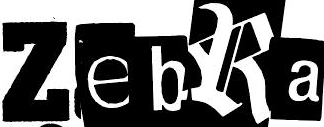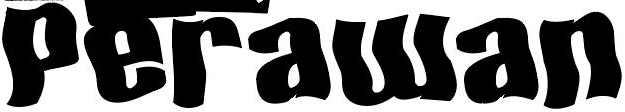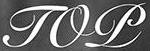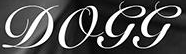Read the text content from these images in order, separated by a semicolon. ZebRa; Perawan; TOP; DOGG 